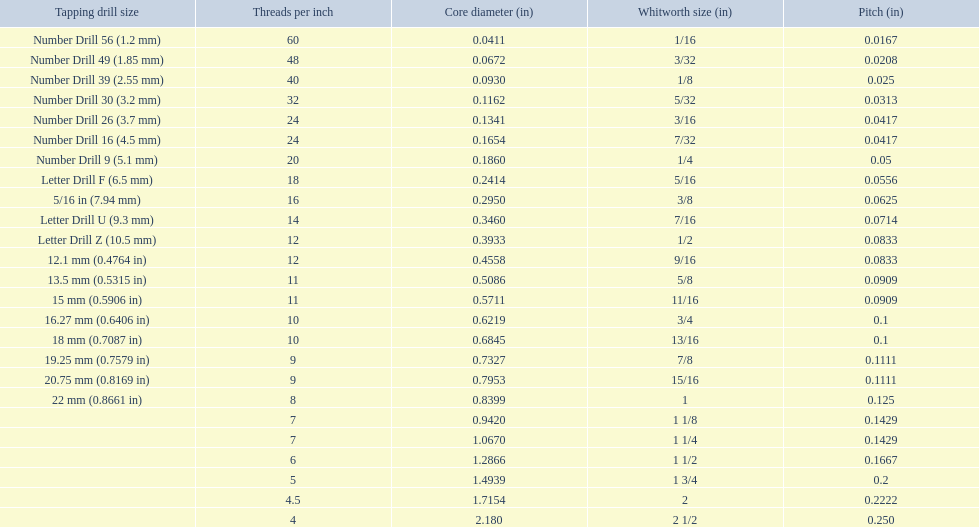What is the core diameter for the number drill 26? 0.1341. What is the whitworth size (in) for this core diameter? 3/16. 